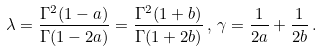Convert formula to latex. <formula><loc_0><loc_0><loc_500><loc_500>\lambda = \frac { \Gamma ^ { 2 } ( 1 - a ) } { \Gamma ( 1 - 2 a ) } = \frac { \Gamma ^ { 2 } ( 1 + b ) } { \Gamma ( 1 + 2 b ) } \, , \, \gamma = \frac { 1 } { 2 a } + \frac { 1 } { 2 b } \, .</formula> 